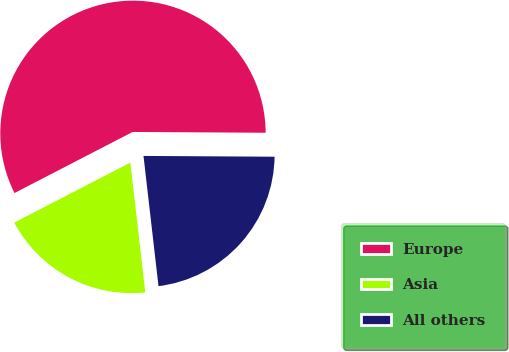Convert chart. <chart><loc_0><loc_0><loc_500><loc_500><pie_chart><fcel>Europe<fcel>Asia<fcel>All others<nl><fcel>57.69%<fcel>19.23%<fcel>23.08%<nl></chart> 